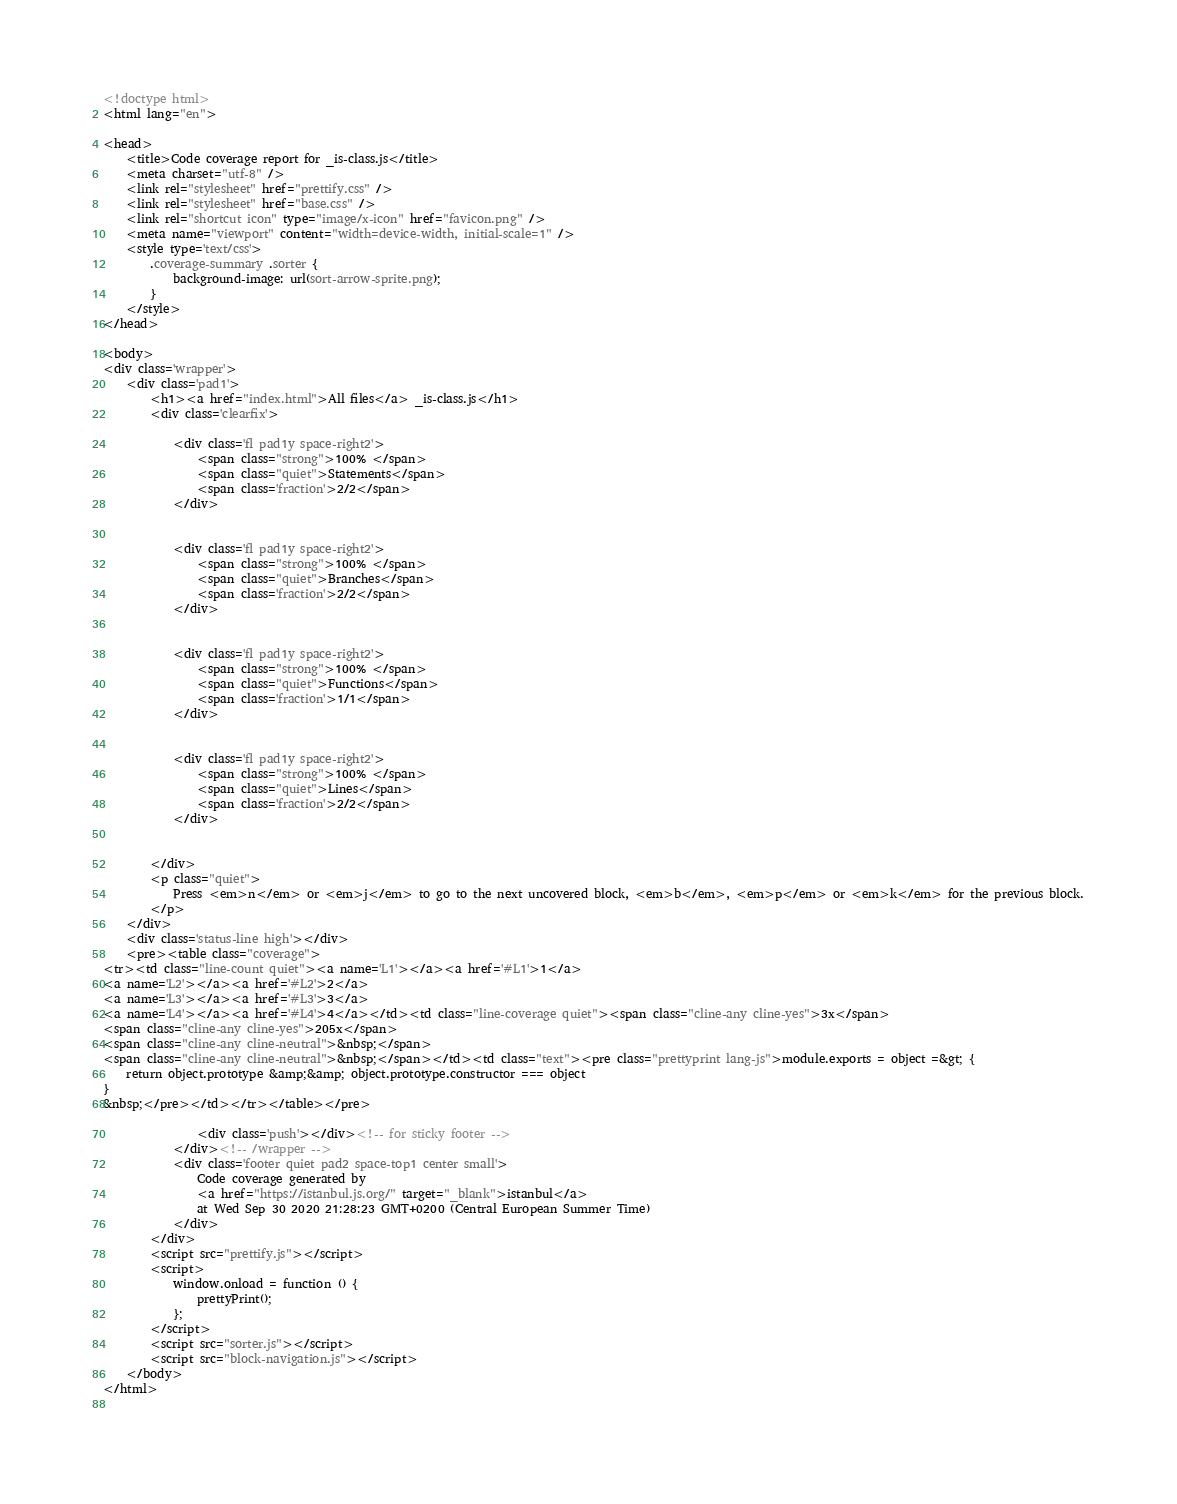Convert code to text. <code><loc_0><loc_0><loc_500><loc_500><_HTML_>
<!doctype html>
<html lang="en">

<head>
    <title>Code coverage report for _is-class.js</title>
    <meta charset="utf-8" />
    <link rel="stylesheet" href="prettify.css" />
    <link rel="stylesheet" href="base.css" />
    <link rel="shortcut icon" type="image/x-icon" href="favicon.png" />
    <meta name="viewport" content="width=device-width, initial-scale=1" />
    <style type='text/css'>
        .coverage-summary .sorter {
            background-image: url(sort-arrow-sprite.png);
        }
    </style>
</head>
    
<body>
<div class='wrapper'>
    <div class='pad1'>
        <h1><a href="index.html">All files</a> _is-class.js</h1>
        <div class='clearfix'>
            
            <div class='fl pad1y space-right2'>
                <span class="strong">100% </span>
                <span class="quiet">Statements</span>
                <span class='fraction'>2/2</span>
            </div>
        
            
            <div class='fl pad1y space-right2'>
                <span class="strong">100% </span>
                <span class="quiet">Branches</span>
                <span class='fraction'>2/2</span>
            </div>
        
            
            <div class='fl pad1y space-right2'>
                <span class="strong">100% </span>
                <span class="quiet">Functions</span>
                <span class='fraction'>1/1</span>
            </div>
        
            
            <div class='fl pad1y space-right2'>
                <span class="strong">100% </span>
                <span class="quiet">Lines</span>
                <span class='fraction'>2/2</span>
            </div>
        
            
        </div>
        <p class="quiet">
            Press <em>n</em> or <em>j</em> to go to the next uncovered block, <em>b</em>, <em>p</em> or <em>k</em> for the previous block.
        </p>
    </div>
    <div class='status-line high'></div>
    <pre><table class="coverage">
<tr><td class="line-count quiet"><a name='L1'></a><a href='#L1'>1</a>
<a name='L2'></a><a href='#L2'>2</a>
<a name='L3'></a><a href='#L3'>3</a>
<a name='L4'></a><a href='#L4'>4</a></td><td class="line-coverage quiet"><span class="cline-any cline-yes">3x</span>
<span class="cline-any cline-yes">205x</span>
<span class="cline-any cline-neutral">&nbsp;</span>
<span class="cline-any cline-neutral">&nbsp;</span></td><td class="text"><pre class="prettyprint lang-js">module.exports = object =&gt; {
    return object.prototype &amp;&amp; object.prototype.constructor === object
}
&nbsp;</pre></td></tr></table></pre>

                <div class='push'></div><!-- for sticky footer -->
            </div><!-- /wrapper -->
            <div class='footer quiet pad2 space-top1 center small'>
                Code coverage generated by
                <a href="https://istanbul.js.org/" target="_blank">istanbul</a>
                at Wed Sep 30 2020 21:28:23 GMT+0200 (Central European Summer Time)
            </div>
        </div>
        <script src="prettify.js"></script>
        <script>
            window.onload = function () {
                prettyPrint();
            };
        </script>
        <script src="sorter.js"></script>
        <script src="block-navigation.js"></script>
    </body>
</html>
    </code> 